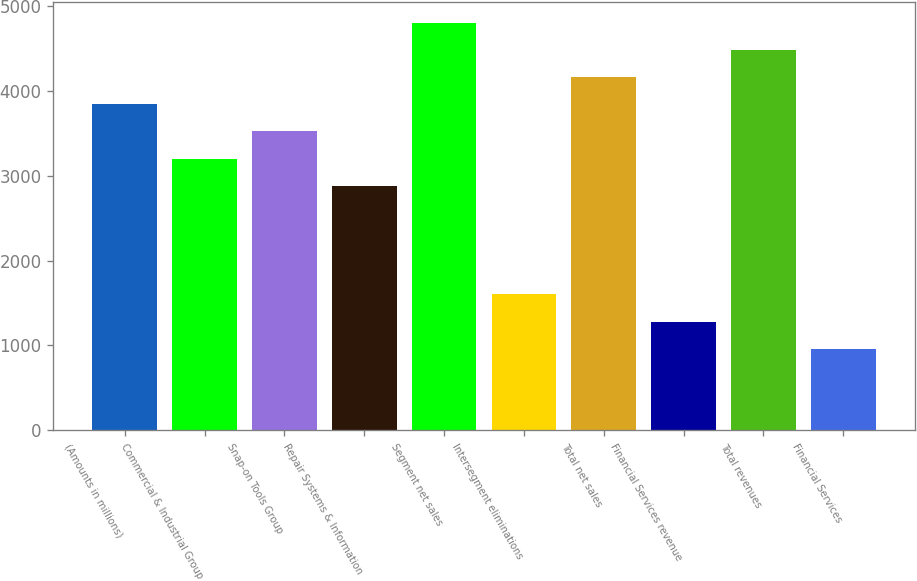Convert chart to OTSL. <chart><loc_0><loc_0><loc_500><loc_500><bar_chart><fcel>(Amounts in millions)<fcel>Commercial & Industrial Group<fcel>Snap-on Tools Group<fcel>Repair Systems & Information<fcel>Segment net sales<fcel>Intersegment eliminations<fcel>Total net sales<fcel>Financial Services revenue<fcel>Total revenues<fcel>Financial Services<nl><fcel>3839.56<fcel>3199.8<fcel>3519.68<fcel>2879.92<fcel>4799.2<fcel>1600.4<fcel>4159.44<fcel>1280.52<fcel>4479.32<fcel>960.64<nl></chart> 